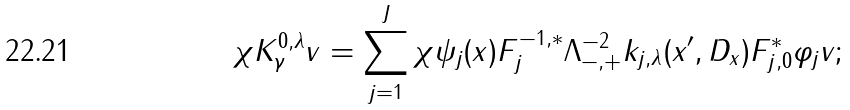<formula> <loc_0><loc_0><loc_500><loc_500>\chi K _ { \gamma } ^ { 0 , \lambda } v = \sum _ { j = 1 } ^ { J } \chi \psi _ { j } ( x ) F ^ { - 1 , \ast } _ { j } \Lambda _ { - , + } ^ { - 2 } k _ { j , \lambda } ( x ^ { \prime } , D _ { x } ) F ^ { \ast } _ { j , 0 } \varphi _ { j } v ;</formula> 